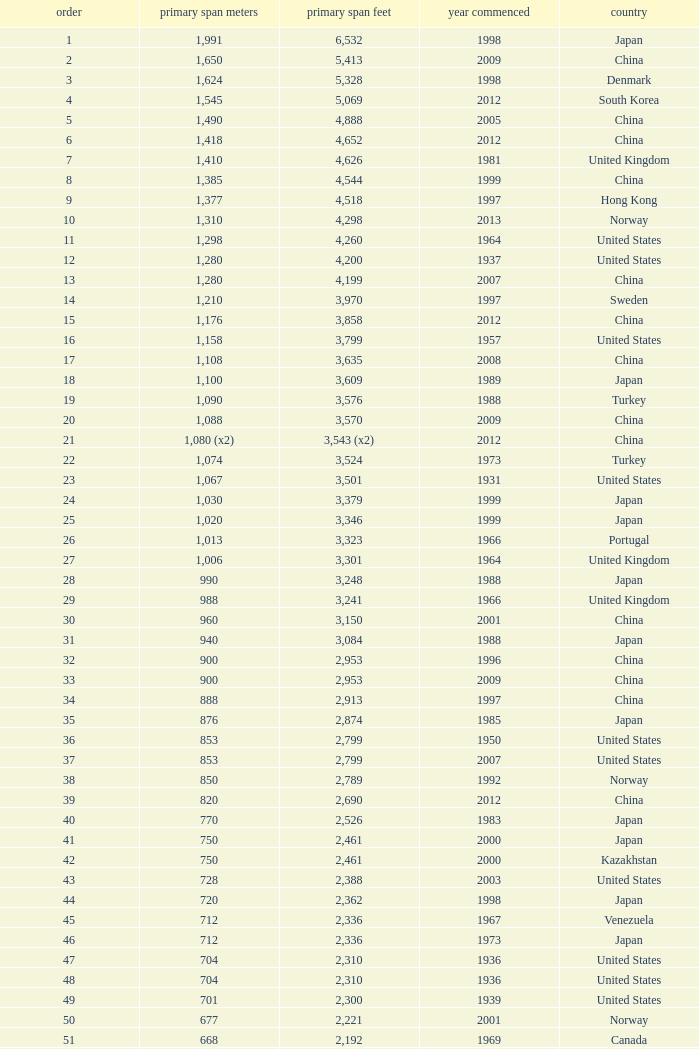What is the main span feet from opening year of 1936 in the United States with a rank greater than 47 and 421 main span metres? 1381.0. 